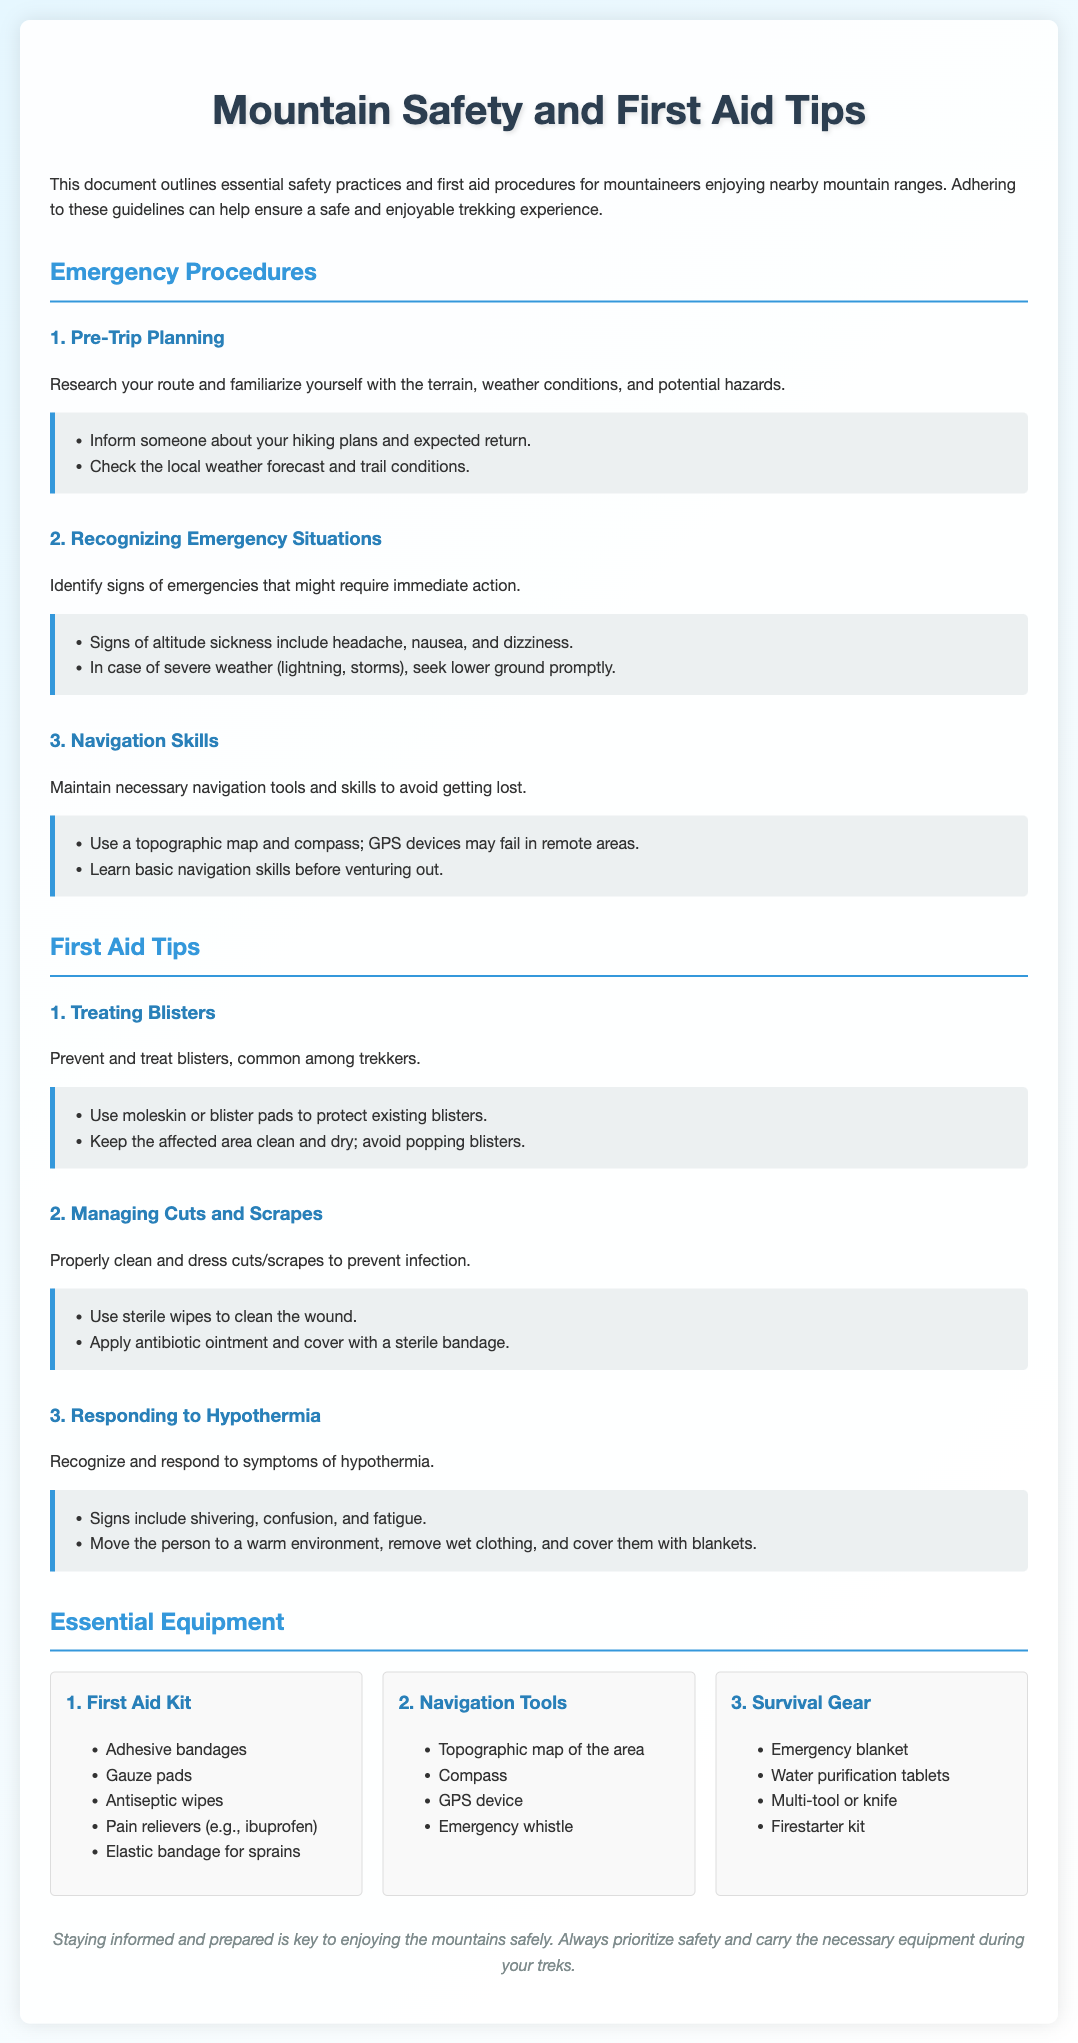What are the key signs of altitude sickness? The document lists signs of altitude sickness, which include headache, nausea, and dizziness.
Answer: headache, nausea, and dizziness What should you do in case of severe weather? The document states that in case of severe weather, one should seek lower ground promptly.
Answer: seek lower ground promptly What is an essential item in a First Aid Kit? The document includes several items, one of which is adhesive bandages.
Answer: adhesive bandages How should blisters be treated? The document advises using moleskin or blister pads to protect existing blisters and keeping the area clean and dry.
Answer: use moleskin or blister pads What navigation tools are recommended? Navigation tools mentioned include a topographic map, compass, and GPS device.
Answer: topographic map, compass, GPS device What symptoms indicate hypothermia? The document indicates that signs of hypothermia include shivering, confusion, and fatigue.
Answer: shivering, confusion, and fatigue How many key emergency procedures are listed? The document lists three key emergency procedures regarding mountain safety.
Answer: three What type of gear is suggested for survival? The document suggests carrying an emergency blanket and water purification tablets as part of survival gear.
Answer: emergency blanket, water purification tablets What should you do if you get a cut or scrape? According to the document, you should clean the wound using sterile wipes and apply antibiotic ointment.
Answer: clean with sterile wipes and apply antibiotic ointment 